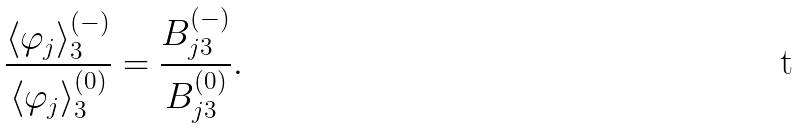<formula> <loc_0><loc_0><loc_500><loc_500>\frac { \langle \varphi _ { j } \rangle _ { 3 } ^ { ( - ) } } { \langle \varphi _ { j } \rangle _ { 3 } ^ { ( 0 ) } } = \frac { B _ { j 3 } ^ { ( - ) } } { B _ { j 3 } ^ { ( 0 ) } } .</formula> 